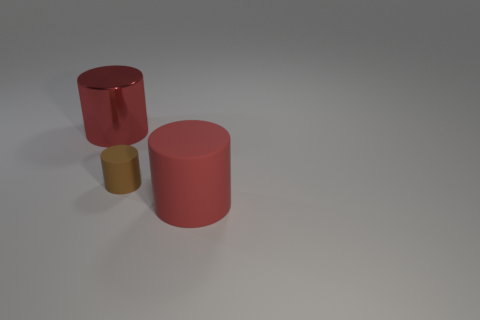Add 3 tiny matte things. How many objects exist? 6 Add 3 large things. How many large things exist? 5 Subtract 0 gray cylinders. How many objects are left? 3 Subtract all big blue rubber blocks. Subtract all red objects. How many objects are left? 1 Add 1 metal objects. How many metal objects are left? 2 